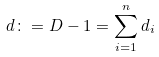Convert formula to latex. <formula><loc_0><loc_0><loc_500><loc_500>d \colon = D - 1 = \sum _ { i = 1 } ^ { n } d _ { i }</formula> 